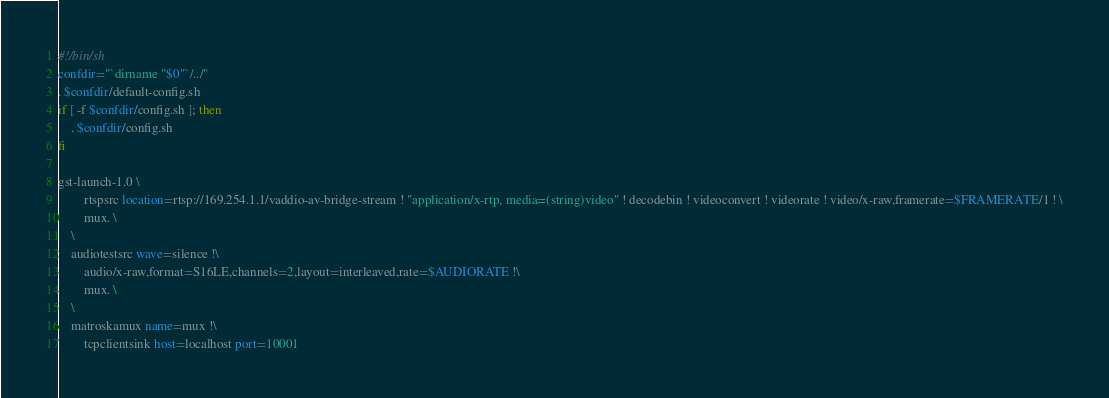Convert code to text. <code><loc_0><loc_0><loc_500><loc_500><_Bash_>#!/bin/sh
confdir="`dirname "$0"`/../"
. $confdir/default-config.sh
if [ -f $confdir/config.sh ]; then
	. $confdir/config.sh
fi

gst-launch-1.0 \
        rtspsrc location=rtsp://169.254.1.1/vaddio-av-bridge-stream ! "application/x-rtp, media=(string)video" ! decodebin ! videoconvert ! videorate ! video/x-raw,framerate=$FRAMERATE/1 ! \
		mux. \
	\
	audiotestsrc wave=silence !\
		audio/x-raw,format=S16LE,channels=2,layout=interleaved,rate=$AUDIORATE !\
		mux. \
	\
	matroskamux name=mux !\
		tcpclientsink host=localhost port=10001
</code> 